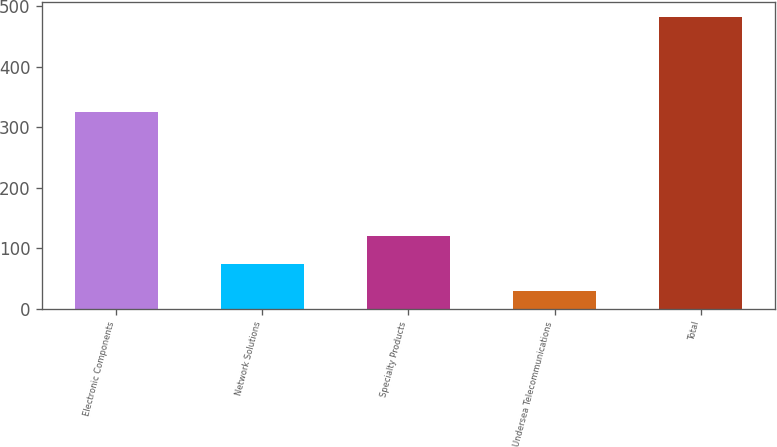Convert chart. <chart><loc_0><loc_0><loc_500><loc_500><bar_chart><fcel>Electronic Components<fcel>Network Solutions<fcel>Specialty Products<fcel>Undersea Telecommunications<fcel>Total<nl><fcel>325<fcel>74.3<fcel>119.6<fcel>29<fcel>482<nl></chart> 